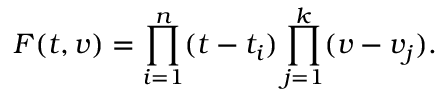Convert formula to latex. <formula><loc_0><loc_0><loc_500><loc_500>F ( t , v ) = \prod _ { i = 1 } ^ { n } ( t - t _ { i } ) \prod _ { j = 1 } ^ { k } ( v - v _ { j } ) .</formula> 